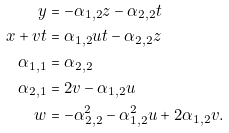Convert formula to latex. <formula><loc_0><loc_0><loc_500><loc_500>y & = - \alpha _ { 1 , 2 } z - \alpha _ { 2 , 2 } t \\ x + v t & = \alpha _ { 1 , 2 } u t - \alpha _ { 2 , 2 } z \\ \alpha _ { 1 , 1 } & = \alpha _ { 2 , 2 } \\ \alpha _ { 2 , 1 } & = 2 v - \alpha _ { 1 , 2 } u \\ w & = - \alpha _ { 2 , 2 } ^ { 2 } - \alpha _ { 1 , 2 } ^ { 2 } u + 2 \alpha _ { 1 , 2 } v .</formula> 